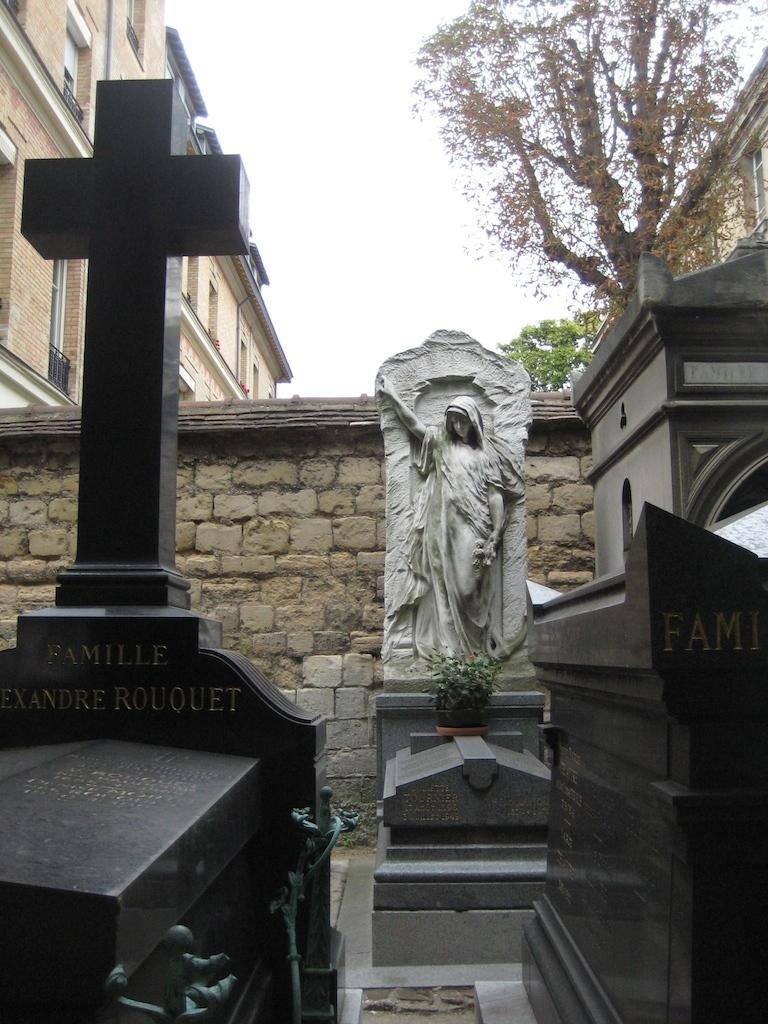What type of structures can be seen in the image? There are buildings in the image. What natural elements are present in the image? There are trees in the image. What part of the sky is visible in the image? The sky is visible in the image. What type of wall can be seen in the image? There is a wall built with cobblestones in the image. What type of memorial or commemoration is present in the image? There are graves in the image. What type of artwork or sculpture is present in the image? There is a statue in the image. Can you tell me how many ladybugs are crawling on the statue in the image? There are no ladybugs present on the statue or anywhere else in the image. What type of harmony is being played by the musicians in the image? There are no musicians or any form of harmony present in the image. 